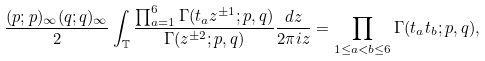Convert formula to latex. <formula><loc_0><loc_0><loc_500><loc_500>\frac { ( p ; p ) _ { \infty } ( q ; q ) _ { \infty } } { 2 } \int _ { \mathbb { T } } \frac { \prod _ { a = 1 } ^ { 6 } \Gamma ( t _ { a } z ^ { \pm 1 } ; p , q ) } { \Gamma ( z ^ { \pm 2 } ; p , q ) } \frac { d z } { 2 \pi i z } = \prod _ { 1 \leq a < b \leq 6 } \Gamma ( t _ { a } t _ { b } ; p , q ) ,</formula> 